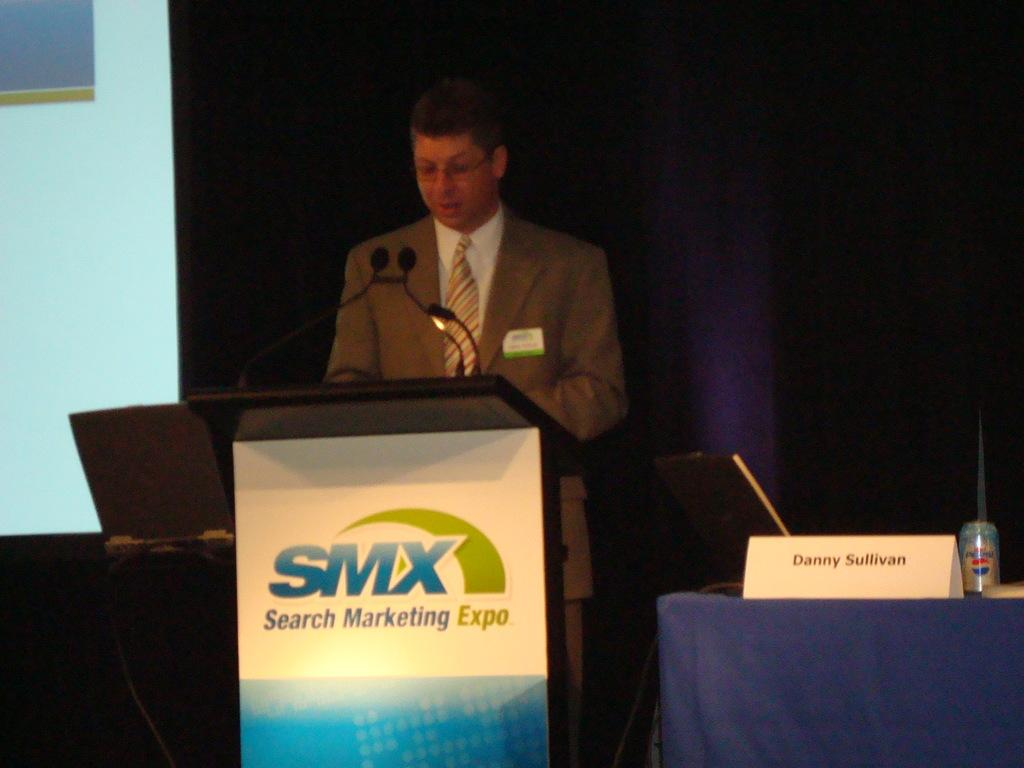<image>
Present a compact description of the photo's key features. Danny Sullivan speaks at the Search Marketing Expo. 